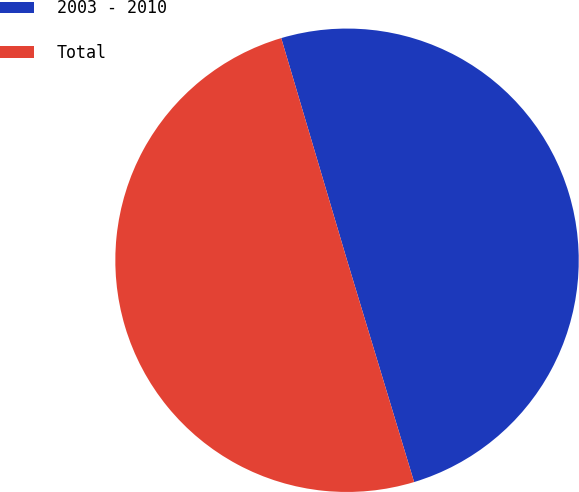Convert chart to OTSL. <chart><loc_0><loc_0><loc_500><loc_500><pie_chart><fcel>2003 - 2010<fcel>Total<nl><fcel>49.91%<fcel>50.09%<nl></chart> 